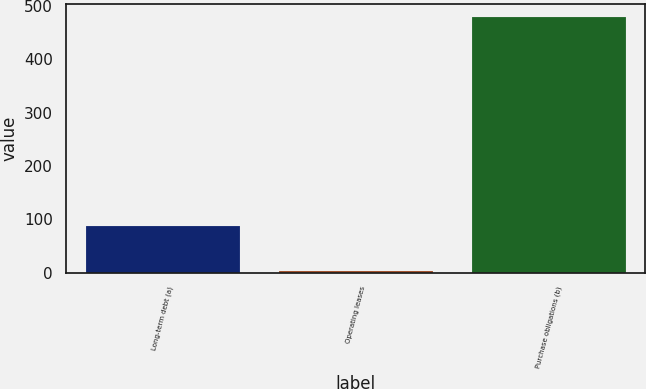Convert chart to OTSL. <chart><loc_0><loc_0><loc_500><loc_500><bar_chart><fcel>Long-term debt (a)<fcel>Operating leases<fcel>Purchase obligations (b)<nl><fcel>87<fcel>3<fcel>480<nl></chart> 